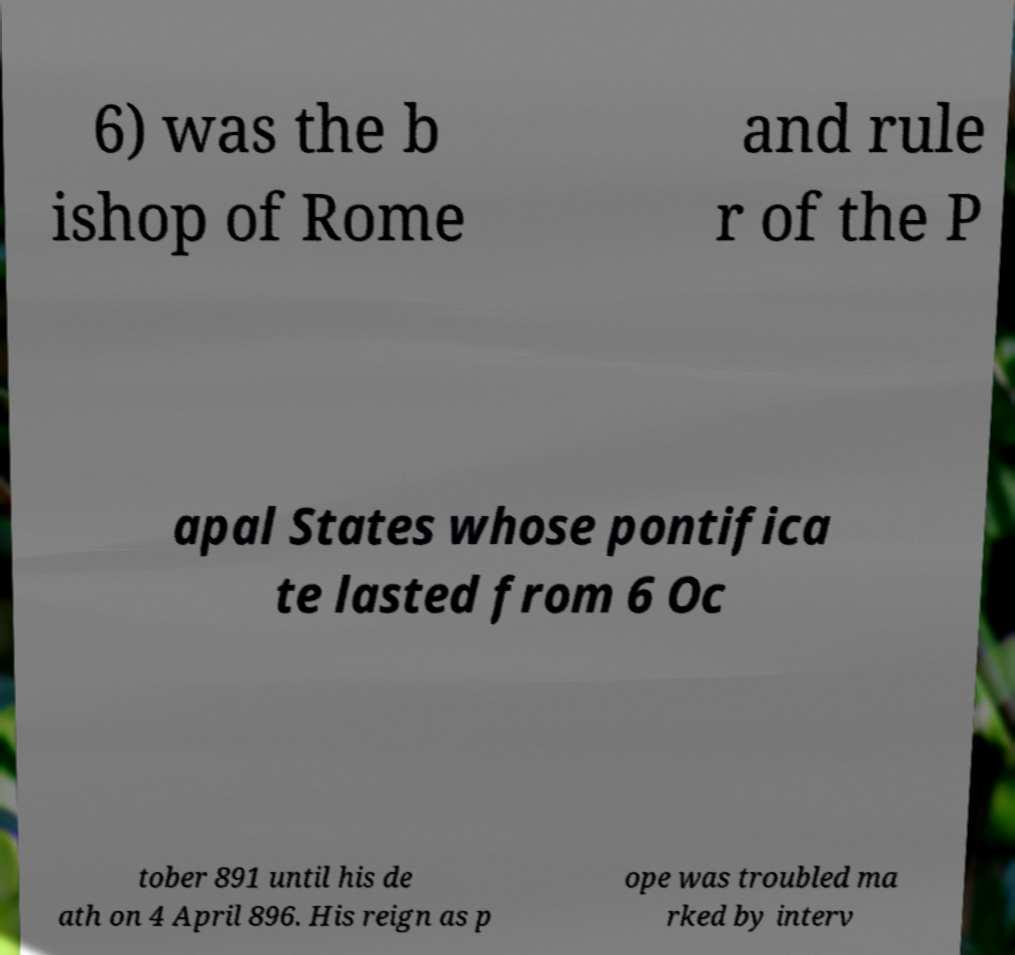Please identify and transcribe the text found in this image. 6) was the b ishop of Rome and rule r of the P apal States whose pontifica te lasted from 6 Oc tober 891 until his de ath on 4 April 896. His reign as p ope was troubled ma rked by interv 